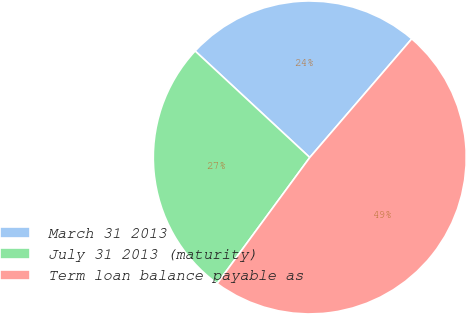Convert chart to OTSL. <chart><loc_0><loc_0><loc_500><loc_500><pie_chart><fcel>March 31 2013<fcel>July 31 2013 (maturity)<fcel>Term loan balance payable as<nl><fcel>24.39%<fcel>26.83%<fcel>48.78%<nl></chart> 